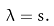Convert formula to latex. <formula><loc_0><loc_0><loc_500><loc_500>\lambda = s .</formula> 